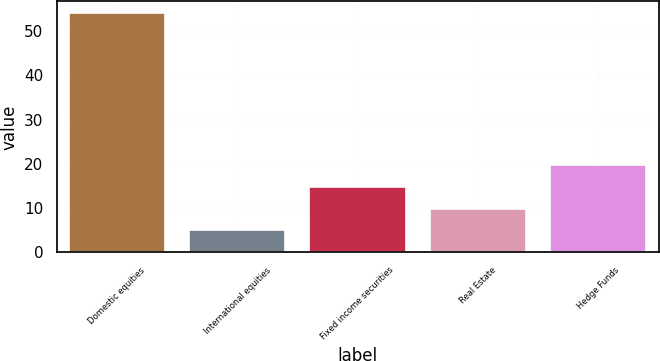Convert chart. <chart><loc_0><loc_0><loc_500><loc_500><bar_chart><fcel>Domestic equities<fcel>International equities<fcel>Fixed income securities<fcel>Real Estate<fcel>Hedge Funds<nl><fcel>54<fcel>5<fcel>14.8<fcel>9.9<fcel>19.7<nl></chart> 